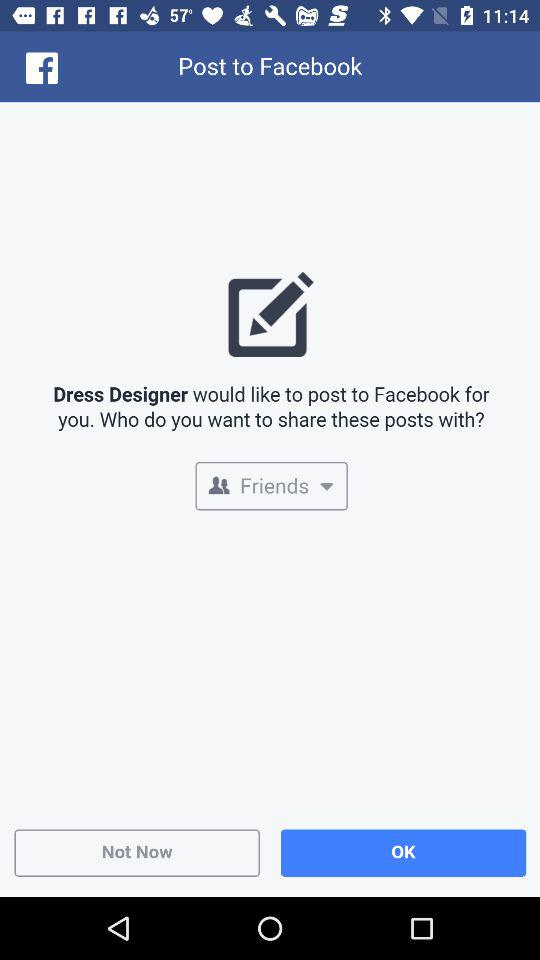Who can see the post from "Dress Designer"? The post from "Dress Designer" can be seen by "Friends". 